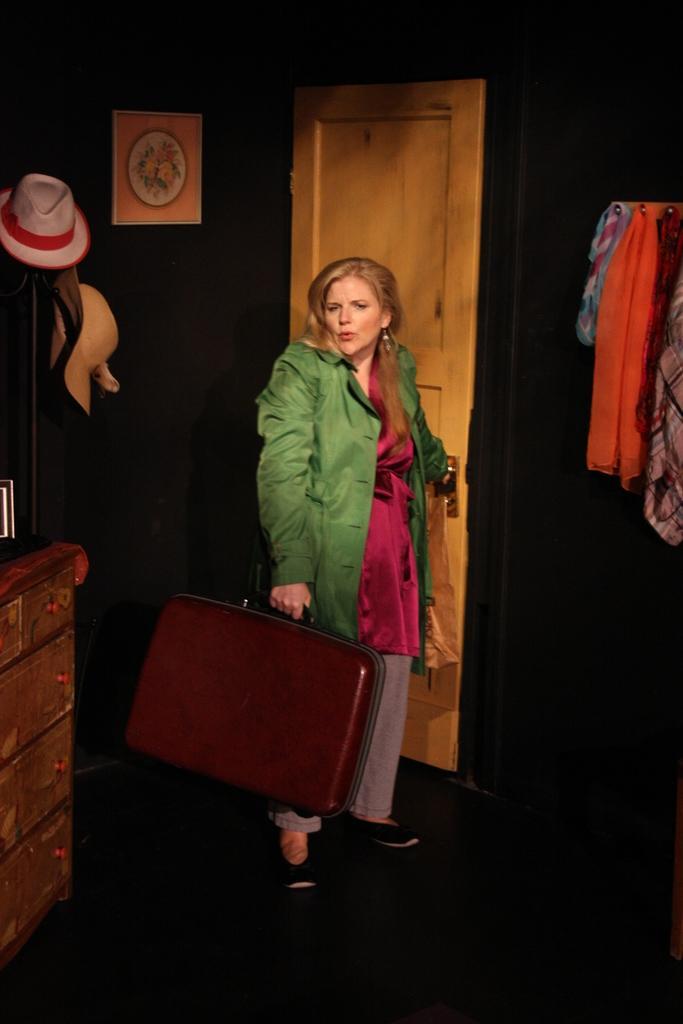Could you give a brief overview of what you see in this image? In the center we can see one woman standing and holding suitcase. On the right side we can see the table and cap. And on the right side we can see the clothes. Coming to the background we can see the door and wall. 